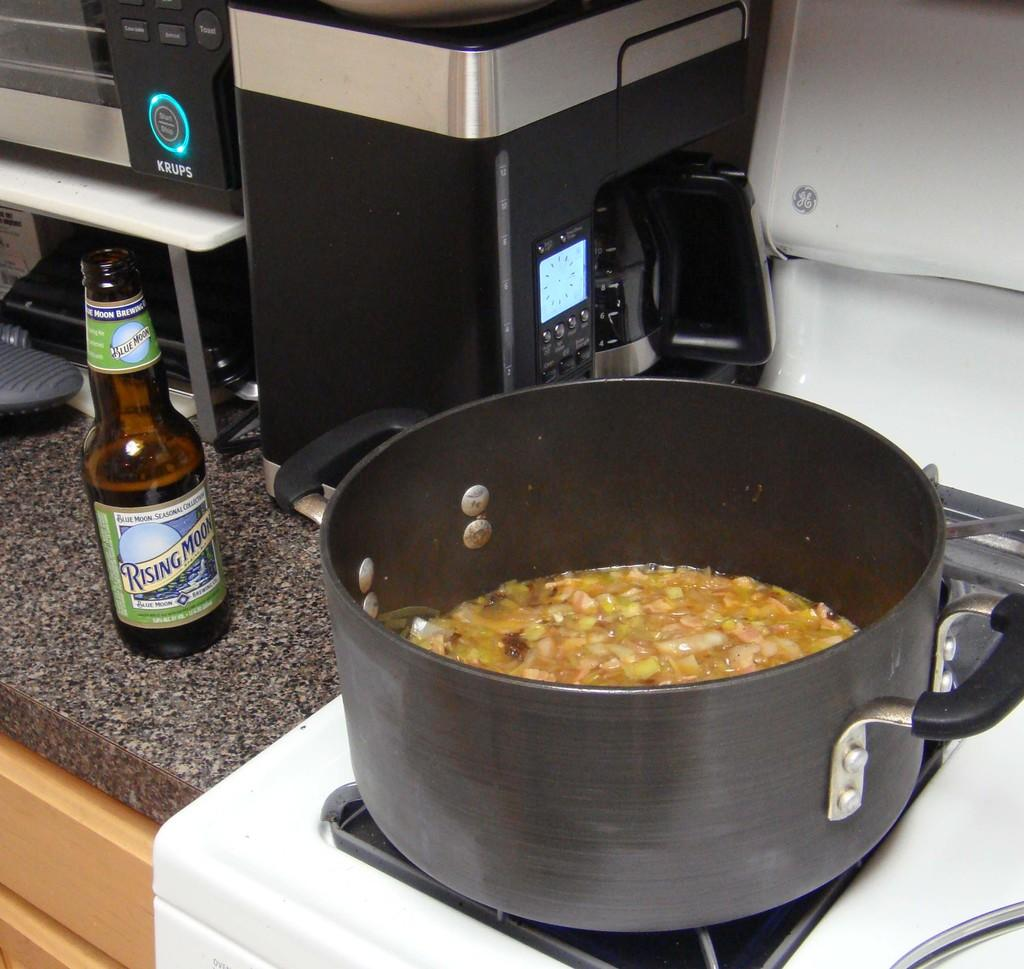<image>
Share a concise interpretation of the image provided. A glass bottle of Rising Moon next to a soup pot. 